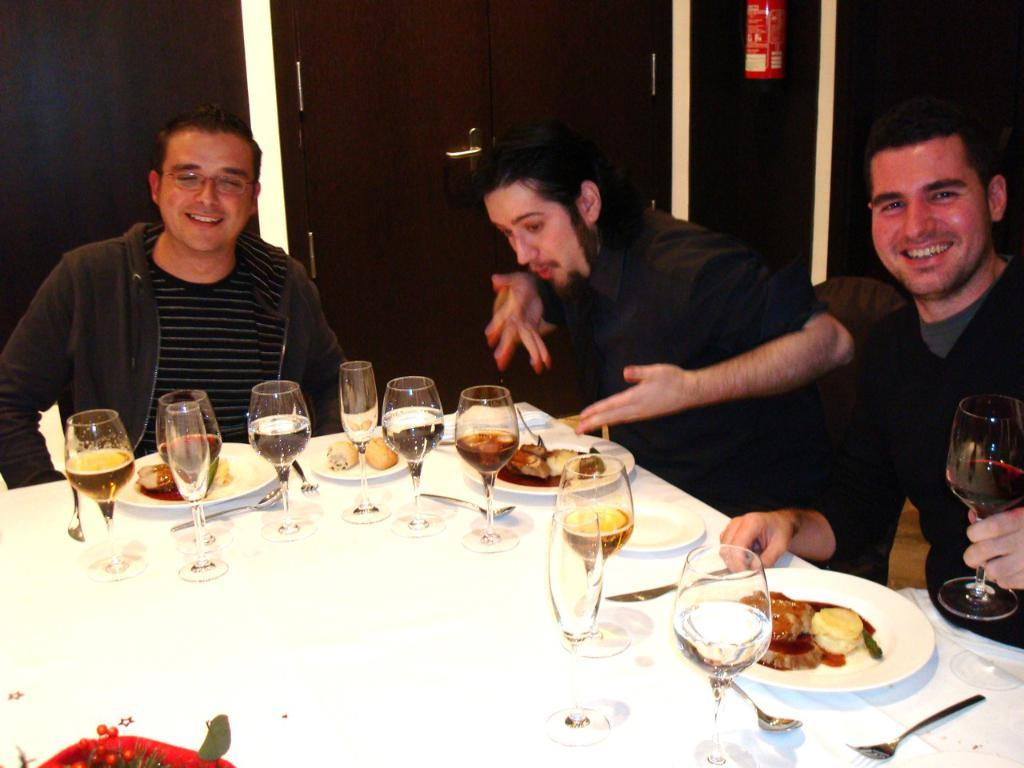How many persons are sitting on the chair in the image? There are three persons sitting on a chair in the image. What is in front of the persons? There is a table in front of the persons. What can be seen on the table? The table has glasses, food items, plates, knives, and forks on it. Can you describe the person holding a glass of wine? One person is holding a glass of wine in the image. What type of news is being broadcasted on the table in the image? There is no news broadcasted on the table in the image; it is a table with glasses, food items, plates, knives, and forks. What kind of nerve can be seen on the table in the image? There are no nerves present on the table in the image; it is a table with glasses, food items, plates, knives, and forks. 